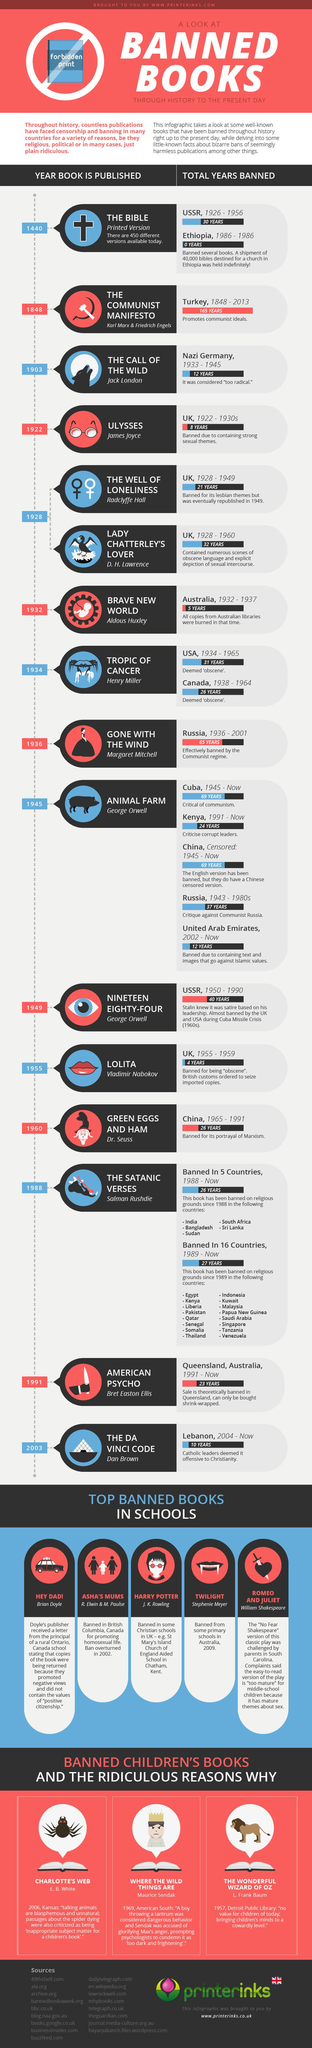Highlight a few significant elements in this photo. The books "Animal Farm" and "Green Eggs and Ham" were banned by China, as indicated by the infographic provided. The books "Ulysses," "The Well of Loneliness," and "Lady Chatterley's Love" were banned by the UK in the 1920s. Out of the books listed in this infographic, the Bible and Nineteen eighty-four were banned by the USSR. In 21 countries, "The Satanic Verses" is banned. Four books in this infographic were banned by the UK. 